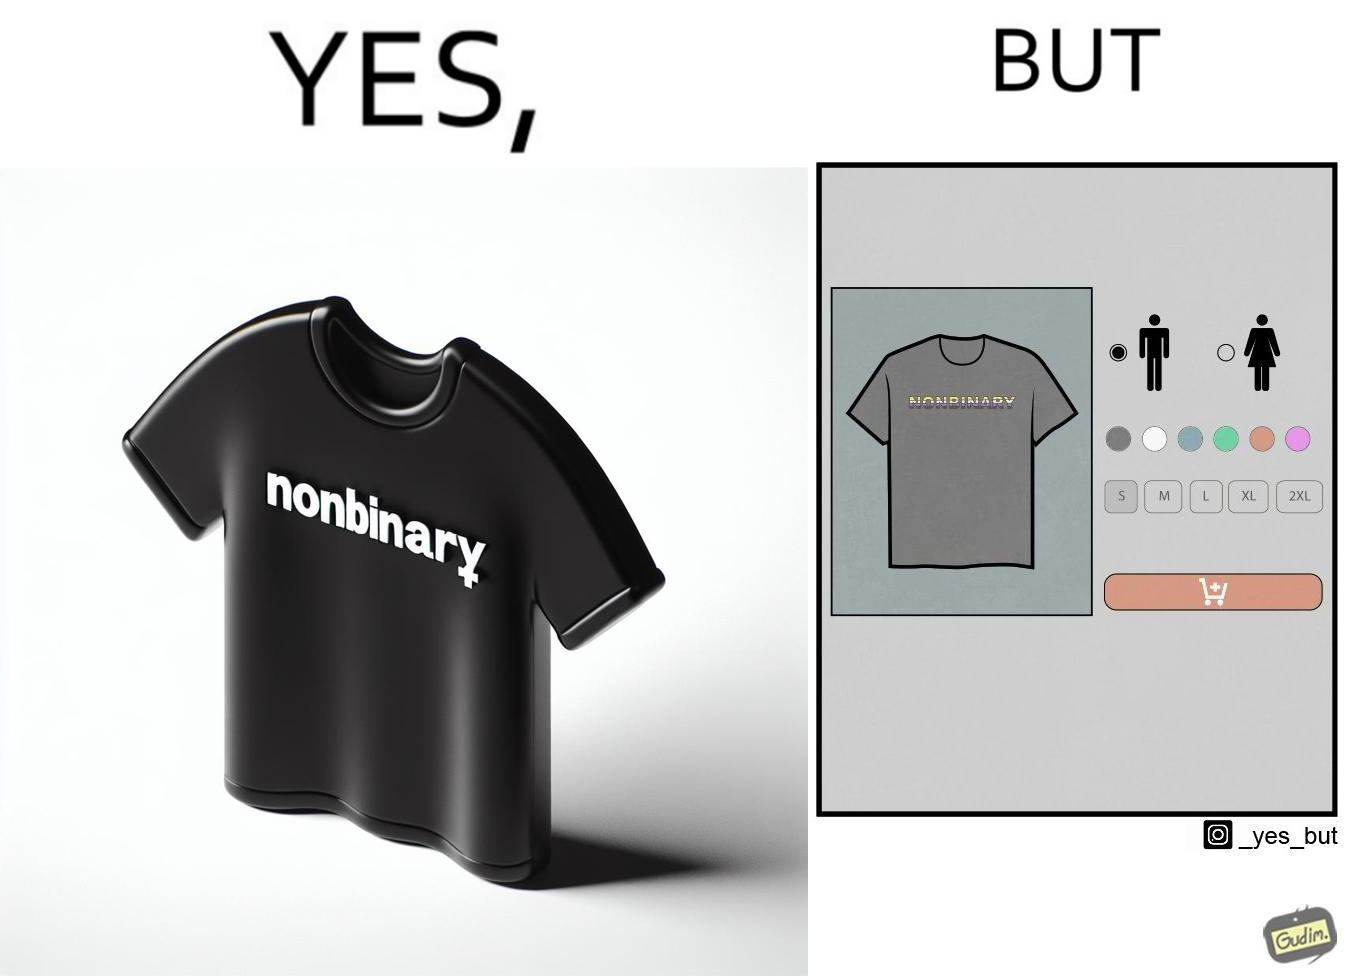What is shown in this image? The image is ironic, as the t-shirt that says "NONBINARY" has only 2 options for gender on an online retail forum. 